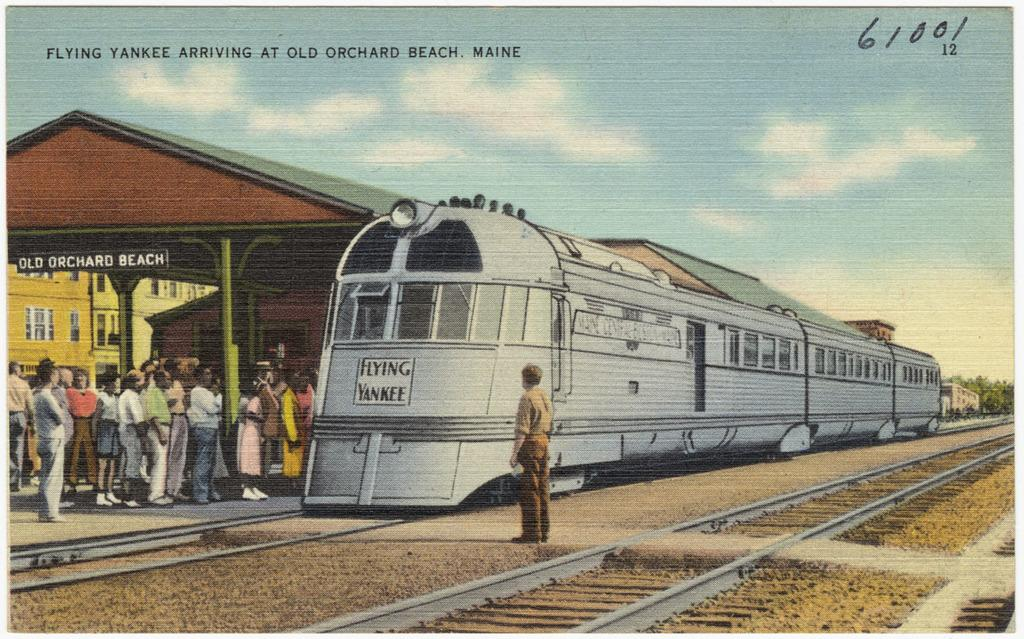<image>
Create a compact narrative representing the image presented. Flying Yankee Train postcard that says Flying Yankee Arriving at Old Orchard Beach Maine 61001. 